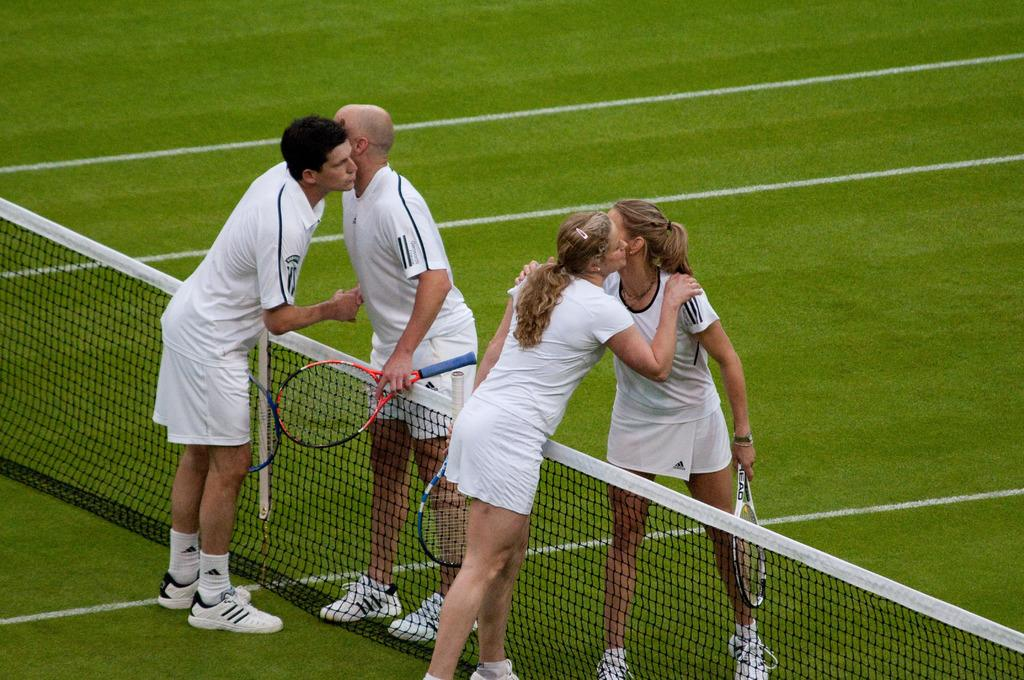How many people are present in the image? There are four people in the image, two men and two women. What are the individuals holding in their hands? They are holding rackets in their hands. What is the surface they are standing on? They are standing on the ground. What can be seen behind the individuals? There is a mesh and grass visible in the image. What type of copper object is being used by the individuals in the image? There is no copper object present in the image; the individuals are holding rackets. Can you tell me how many apples are on the ground in the image? There are no apples present in the image; the ground is covered with grass. 